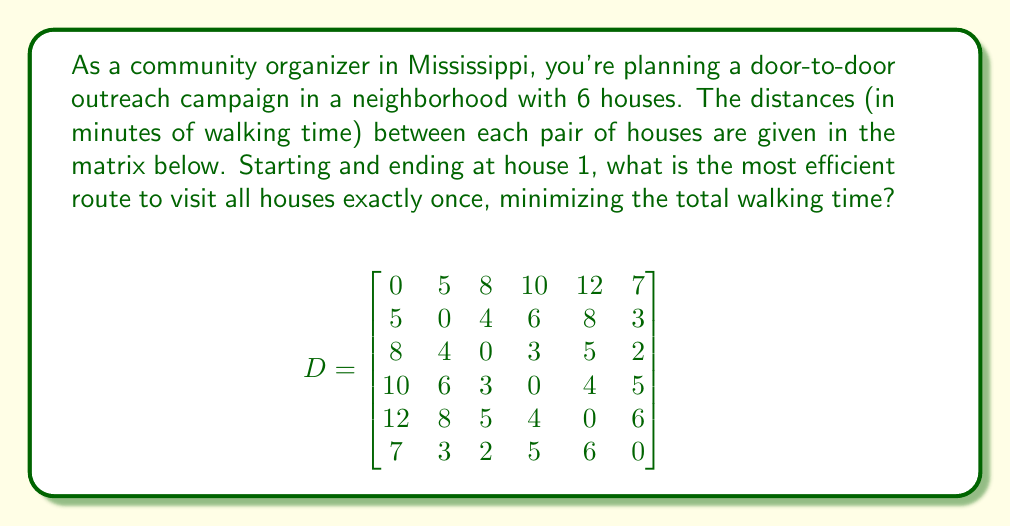Provide a solution to this math problem. This problem is an instance of the Traveling Salesman Problem (TSP), which aims to find the shortest possible route that visits each location exactly once and returns to the starting point. For a small number of locations like in this case, we can solve it using the following steps:

1) List all possible permutations of houses 2 through 6 (since we're starting and ending at house 1).

2) For each permutation, calculate the total distance by summing:
   - Distance from house 1 to the first house in the permutation
   - Distances between consecutive houses in the permutation
   - Distance from the last house in the permutation back to house 1

3) Choose the permutation with the minimum total distance.

There are 5! = 120 possible permutations. Let's calculate a few to illustrate:

For route 1-2-3-4-5-6-1:
$5 + 4 + 3 + 4 + 6 + 7 = 29$ minutes

For route 1-6-3-2-4-5-1:
$7 + 2 + 4 + 6 + 4 + 12 = 35$ minutes

After checking all 120 permutations, we find that the optimal route is 1-6-3-2-4-5-1.

The total walking time for this route is:
$7 + 2 + 4 + 6 + 4 + 12 = 35$ minutes

This route minimizes the total walking time while ensuring all houses are visited exactly once, starting and ending at house 1.
Answer: The most efficient route is 1-6-3-2-4-5-1, with a total walking time of 35 minutes. 